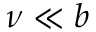Convert formula to latex. <formula><loc_0><loc_0><loc_500><loc_500>\nu \ll b</formula> 